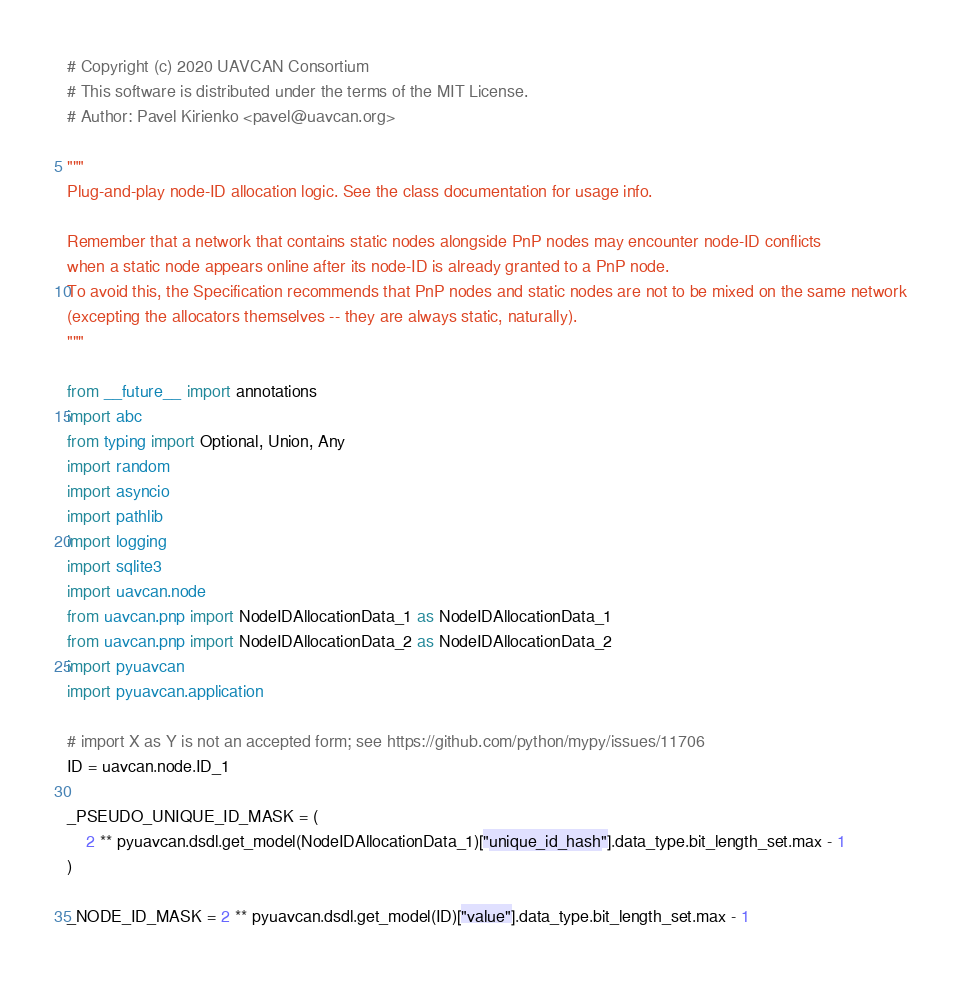Convert code to text. <code><loc_0><loc_0><loc_500><loc_500><_Python_># Copyright (c) 2020 UAVCAN Consortium
# This software is distributed under the terms of the MIT License.
# Author: Pavel Kirienko <pavel@uavcan.org>

"""
Plug-and-play node-ID allocation logic. See the class documentation for usage info.

Remember that a network that contains static nodes alongside PnP nodes may encounter node-ID conflicts
when a static node appears online after its node-ID is already granted to a PnP node.
To avoid this, the Specification recommends that PnP nodes and static nodes are not to be mixed on the same network
(excepting the allocators themselves -- they are always static, naturally).
"""

from __future__ import annotations
import abc
from typing import Optional, Union, Any
import random
import asyncio
import pathlib
import logging
import sqlite3
import uavcan.node
from uavcan.pnp import NodeIDAllocationData_1 as NodeIDAllocationData_1
from uavcan.pnp import NodeIDAllocationData_2 as NodeIDAllocationData_2
import pyuavcan
import pyuavcan.application

# import X as Y is not an accepted form; see https://github.com/python/mypy/issues/11706
ID = uavcan.node.ID_1

_PSEUDO_UNIQUE_ID_MASK = (
    2 ** pyuavcan.dsdl.get_model(NodeIDAllocationData_1)["unique_id_hash"].data_type.bit_length_set.max - 1
)

_NODE_ID_MASK = 2 ** pyuavcan.dsdl.get_model(ID)["value"].data_type.bit_length_set.max - 1
</code> 